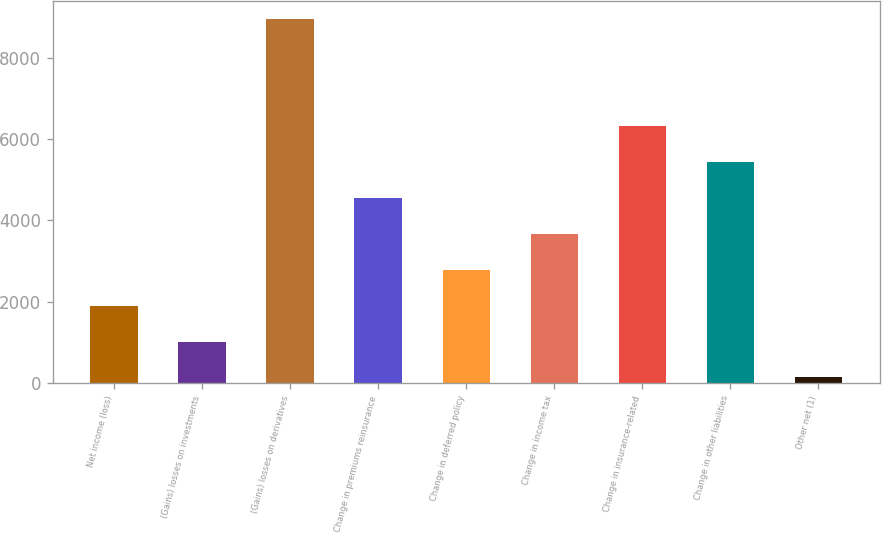<chart> <loc_0><loc_0><loc_500><loc_500><bar_chart><fcel>Net income (loss)<fcel>(Gains) losses on investments<fcel>(Gains) losses on derivatives<fcel>Change in premiums reinsurance<fcel>Change in deferred policy<fcel>Change in income tax<fcel>Change in insurance-related<fcel>Change in other liabilities<fcel>Other net (1)<nl><fcel>1901.4<fcel>1018.7<fcel>8963<fcel>4549.5<fcel>2784.1<fcel>3666.8<fcel>6314.9<fcel>5432.2<fcel>136<nl></chart> 